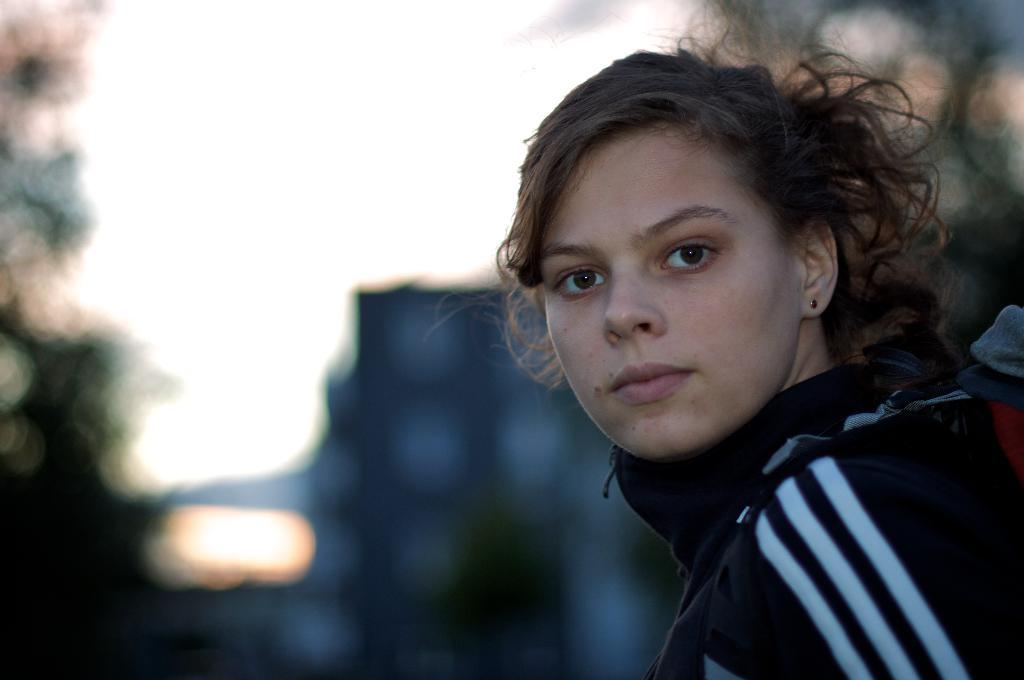Who is present in the image? There is a woman in the image. Can you describe the background of the image? The background of the image is blurry. Are there any flocks of fairies visible in the image? There are no flocks of fairies present in the image. 